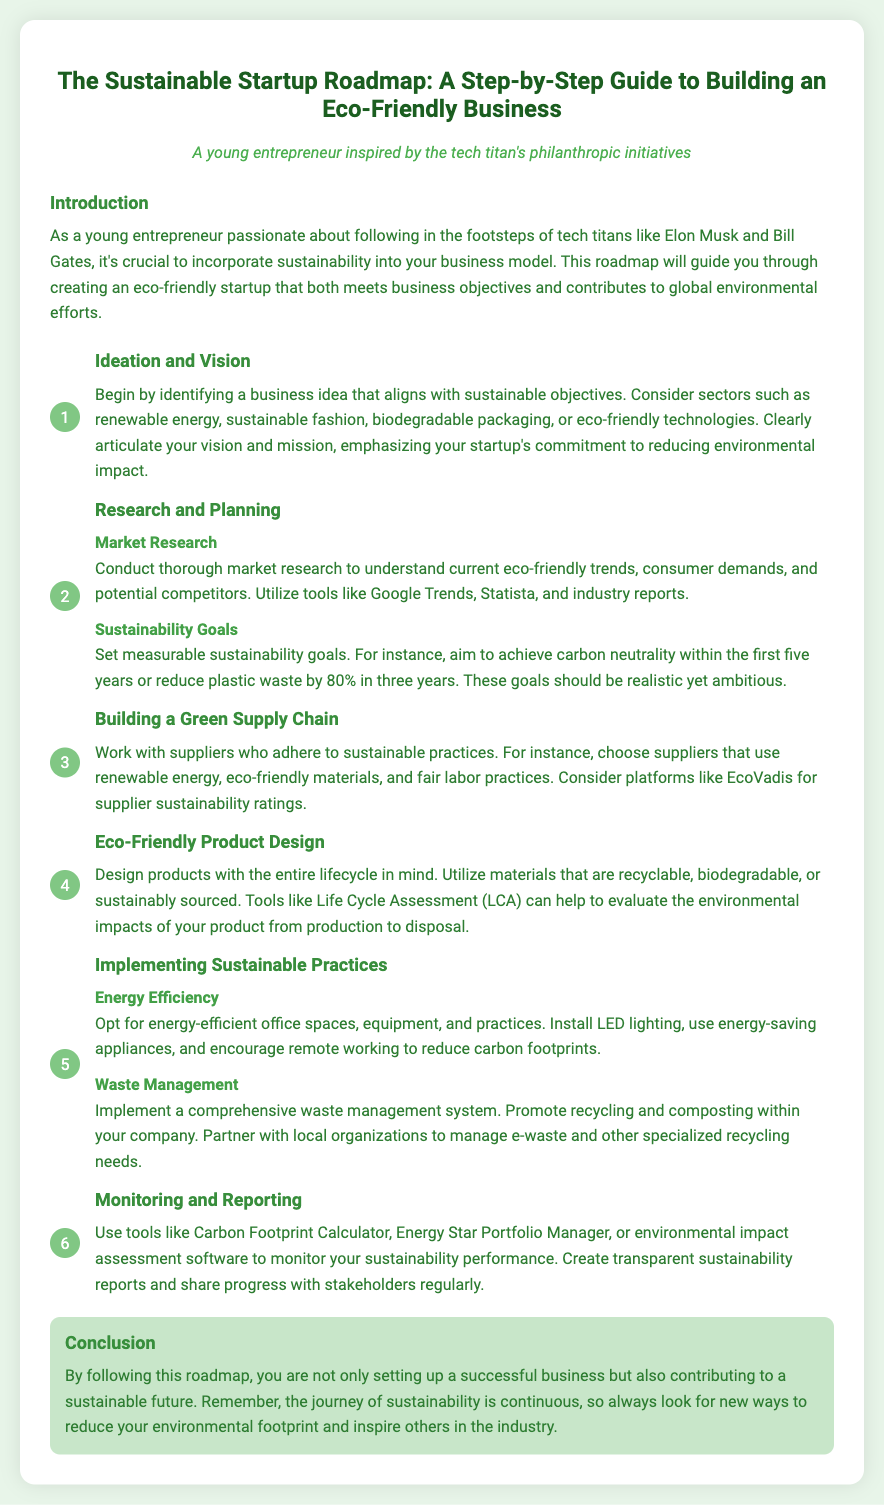What is the title of the document? The title of the document is indicated prominently at the top of the rendered HTML.
Answer: The Sustainable Startup Roadmap: A Step-by-Step Guide to Building an Eco-Friendly Business What is the target audience of the document? The target audience is described in a specific section that highlights their characteristics.
Answer: A young entrepreneur inspired by the tech titan's philanthropic initiatives What is the first step in the roadmap? The first step is outlined in the document, detailing the focus on ideation.
Answer: Ideation and Vision What are two sectors mentioned for sustainable business ideas? Two sectors are provided as examples for potential sustainable businesses within the content.
Answer: Renewable energy, sustainable fashion What is one tool suggested for market research? The document lists various tools for conducting market research, highlighting one specific option.
Answer: Google Trends What is a measurable sustainability goal suggested in the document? A specific example of a sustainability goal is provided within the planning section of the document.
Answer: Achieve carbon neutrality within the first five years What does the step on Eco-Friendly Product Design emphasize? This step highlights a crucial aspect of product development focused on sustainability.
Answer: Design products with the entire lifecycle in mind What is one energy-efficient practice recommended? The text provides examples of practices that can enhance energy efficiency within a business.
Answer: Install LED lighting What is a tool for monitoring sustainability performance? The document mentions several tools for performance monitoring; one specific tool is referenced.
Answer: Carbon Footprint Calculator What is the main conclusion about the journey of sustainability? The document concludes with a general statement about the ongoing nature of sustainability efforts.
Answer: The journey of sustainability is continuous 